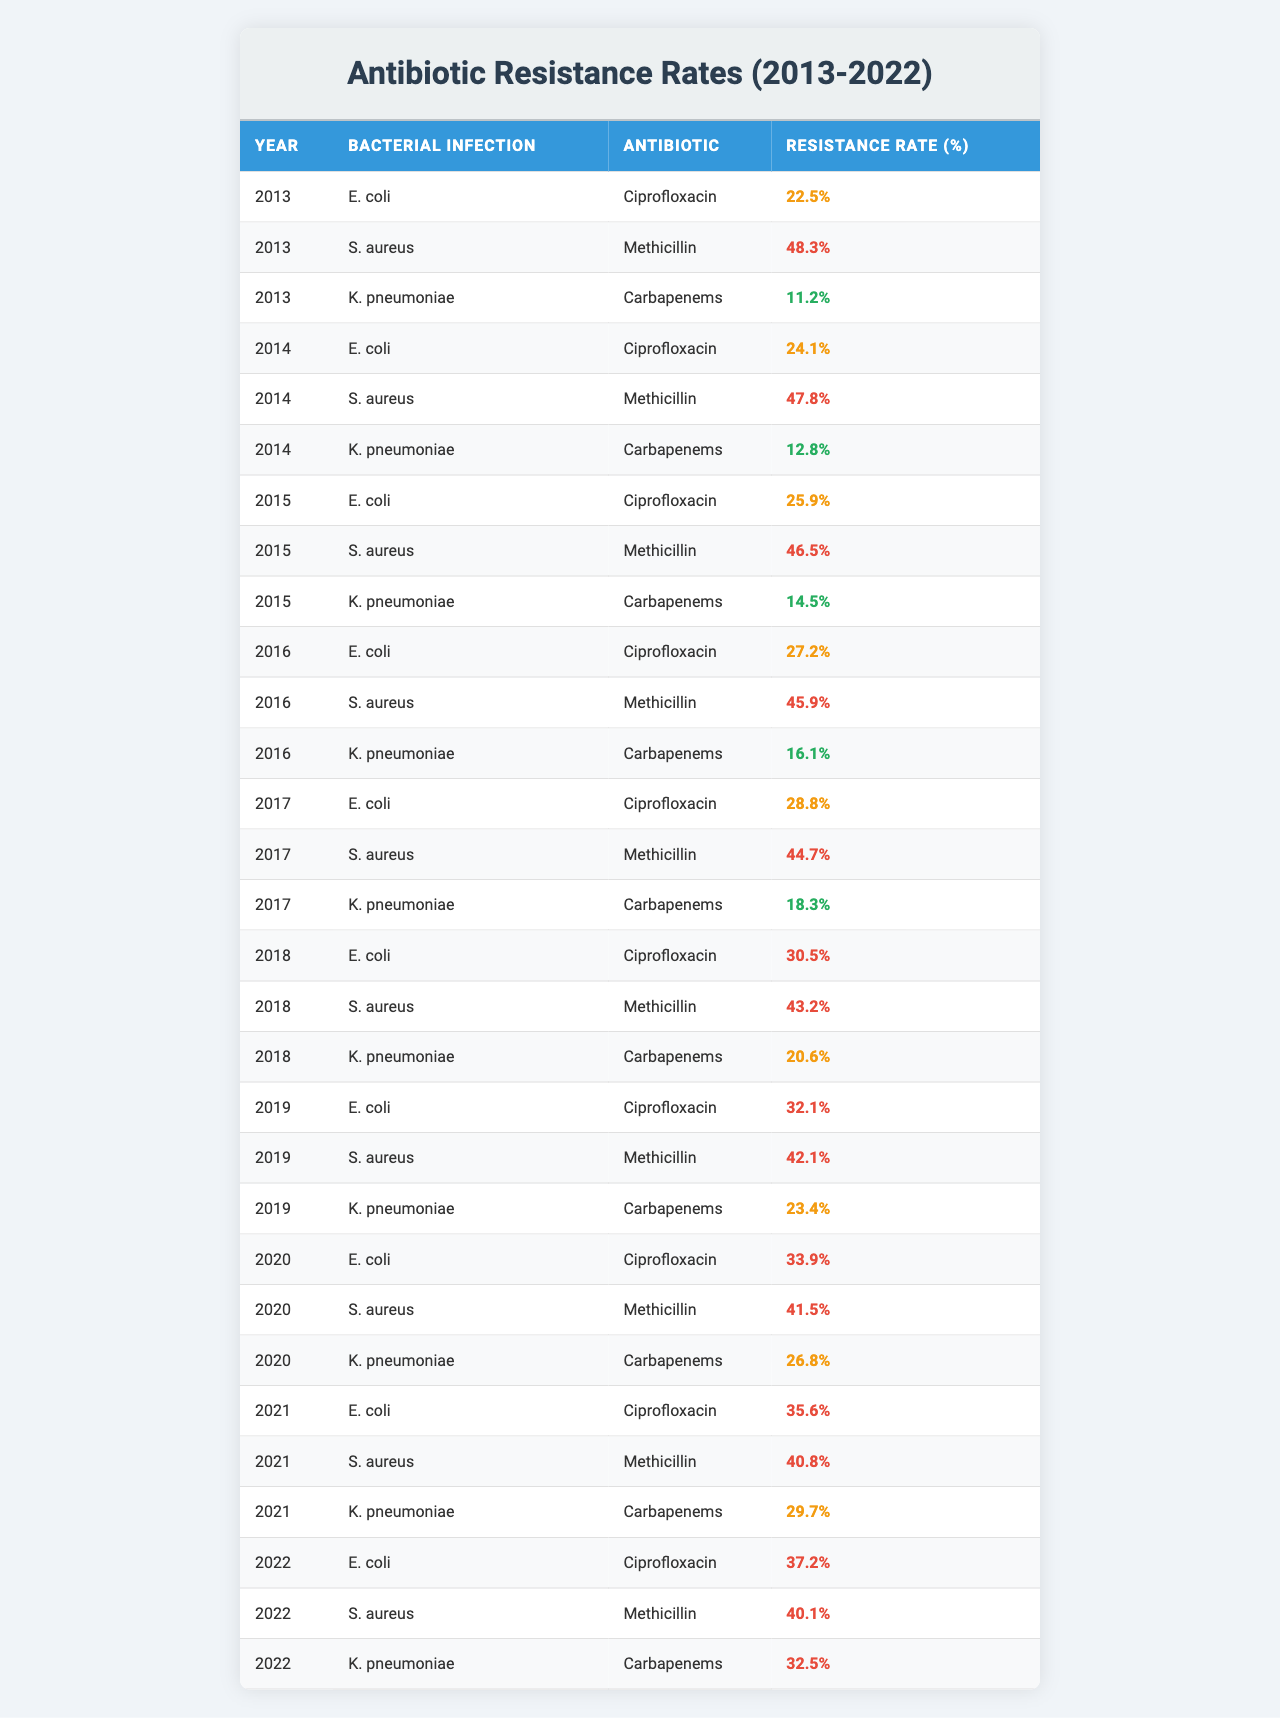What was the resistance rate of E. coli to Ciprofloxacin in 2020? In the table, find the row where the bacterial infection is "E. coli" and the antibiotic is "Ciprofloxacin." In 2020, the resistance rate listed is 33.9%.
Answer: 33.9% Which antibiotic had the highest resistance rate for S. aureus in 2013? Looking at the 2013 data for S. aureus, the antibiotic Methicillin has a resistance rate of 48.3%, while there is no other antibiotic listed for S. aureus in that year. Thus, the highest rate is Methicillin at 48.3%.
Answer: Methicillin What is the trend of resistance rates for K. pneumoniae to Carbapenems from 2013 to 2022? Observing the table, the resistance rates for K. pneumoniae to Carbapenems are 11.2%, 12.8%, 14.5%, 16.1%, 18.3%, 20.6%, 23.4%, 26.8%, 29.7%, and 32.5% from 2013 to 2022, indicating a consistent increase over the years.
Answer: Increasing What is the average resistance rate of E. coli to Ciprofloxacin over the recorded years? The resistance rates for E. coli to Ciprofloxacin from 2013 to 2022 are: 22.5%, 24.1%, 25.9%, 27.2%, 28.8%, 30.5%, 32.1%, 33.9%, 35.6%, and 37.2%. Sum these values to get  24.5 + 25.9 + 27.2 + 28.8 + 30.5 + 32.1 + 33.9 + 35.6 + 37.2 =  274.1, and divide by 10 (the number of years) to get an average of 27.41%.
Answer: 27.41% Did the resistance rate for Methicillin in S. aureus ever exceed 50% during the decade? By checking the table, the resistance rates for Methicillin in S. aureus from 2013 to 2022 are: 48.3%, 47.8%, 46.5%, 45.9%, 44.7%, 43.2%, 42.1%, 41.5%, 40.8%, and 40.1%. None of these values exceed 50%, thus the answer is no.
Answer: No Which year saw the largest increase in the resistance rate of K. pneumoniae to Carbapenems? Analyzing the resistance rates for K. pneumoniae to Carbapenems, the rates are: 11.2% in 2013, 12.8% in 2014 (a 1.6% increase), 14.5% in 2015 (a 1.7% increase), 16.1% in 2016 (a 1.6% increase), 18.3% in 2017 (a 2.2% increase), 20.6% in 2018 (a 2.3% increase), 23.4% in 2019 (a 2.8% increase), 26.8% in 2020 (a 3.4% increase), 29.7% in 2021 (a 2.9% increase), and 32.5% in 2022 (a 2.8% increase). The largest increase is 3.4% from 2019 to 2020.
Answer: 3.4% increase (2019-2020) What bacterial infection showed a consistent increase in antibiotic resistance over the decade? Reviewing the table, E. coli, S. aureus, and K. pneumoniae all exhibit increasing resistance rates over the years for their respective antibiotics. However, K. pneumoniae to Carbapenems shows a steady increase across all years listed.
Answer: K. pneumoniae to Carbapenems Which antibiotic had the lowest resistance rate for K. pneumoniae in 2013? In the 2013 row for K. pneumoniae, the antibiotic Carbapenems has a resistance rate of 11.2%, while there are no other antibiotics for K. pneumoniae listed in that year. Therefore, Carbapenems has the lowest resistance rate.
Answer: Carbapenems Was the resistance rate of E. coli to Ciprofloxacin higher than 30% in 2021? In the table, the resistance rate of E. coli to Ciprofloxacin in 2021 is 35.6%, which is greater than 30%. Thus, the answer is yes.
Answer: Yes What is the overall trend for antibiotic resistance rates in the last decade? The table shows that all listed bacterial infections have increasing resistance rates over the last decade from their initial rates in 2013 to their rates in 2022, indicating worsening antibiotic resistance.
Answer: Worsening resistance trend 